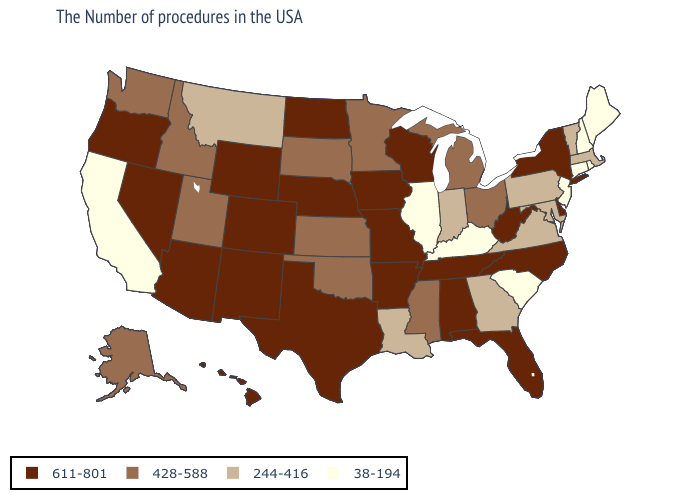Does Oklahoma have the highest value in the USA?
Answer briefly. No. What is the value of New Mexico?
Short answer required. 611-801. What is the highest value in the USA?
Be succinct. 611-801. What is the value of Arizona?
Keep it brief. 611-801. Which states have the lowest value in the South?
Quick response, please. South Carolina, Kentucky. Name the states that have a value in the range 428-588?
Write a very short answer. Ohio, Michigan, Mississippi, Minnesota, Kansas, Oklahoma, South Dakota, Utah, Idaho, Washington, Alaska. Among the states that border Mississippi , which have the lowest value?
Answer briefly. Louisiana. Does South Carolina have a lower value than Kentucky?
Write a very short answer. No. What is the value of Indiana?
Write a very short answer. 244-416. Name the states that have a value in the range 244-416?
Keep it brief. Massachusetts, Vermont, Maryland, Pennsylvania, Virginia, Georgia, Indiana, Louisiana, Montana. What is the value of South Dakota?
Quick response, please. 428-588. Does California have the lowest value in the West?
Write a very short answer. Yes. What is the value of Indiana?
Concise answer only. 244-416. Does Michigan have the highest value in the MidWest?
Give a very brief answer. No. 